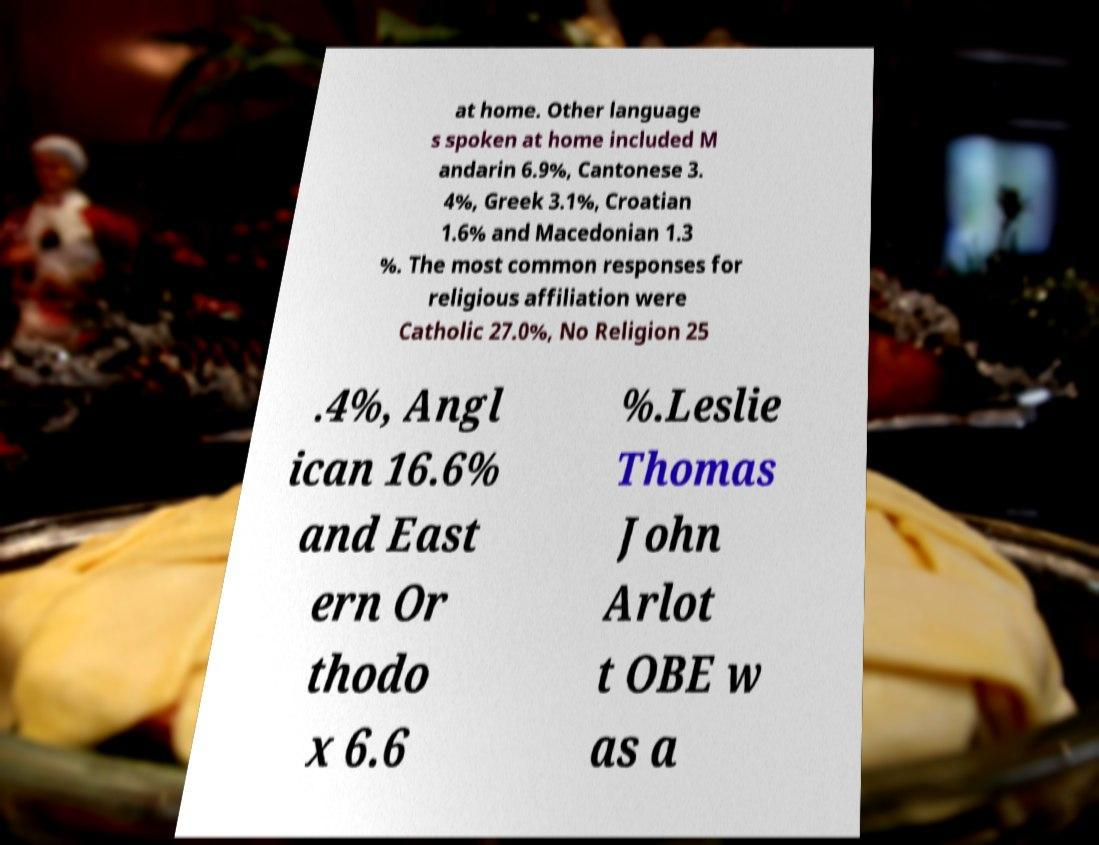Could you assist in decoding the text presented in this image and type it out clearly? at home. Other language s spoken at home included M andarin 6.9%, Cantonese 3. 4%, Greek 3.1%, Croatian 1.6% and Macedonian 1.3 %. The most common responses for religious affiliation were Catholic 27.0%, No Religion 25 .4%, Angl ican 16.6% and East ern Or thodo x 6.6 %.Leslie Thomas John Arlot t OBE w as a 